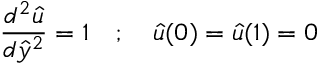<formula> <loc_0><loc_0><loc_500><loc_500>{ \frac { d ^ { 2 } { \hat { u } } } { d { \hat { y } } ^ { 2 } } } = 1 \quad ; \quad \hat { u } ( 0 ) = { \hat { u } } ( 1 ) = 0</formula> 